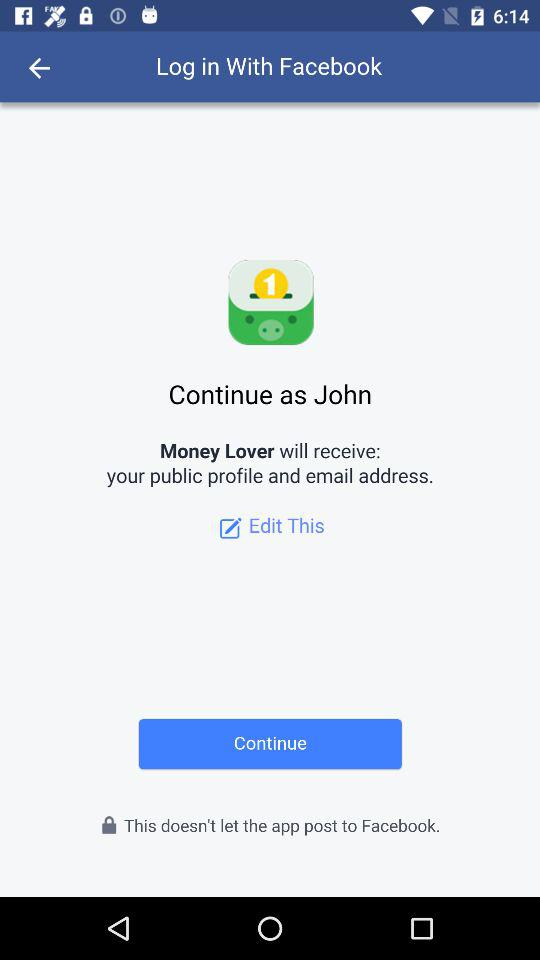How many options do we have to edit profile?
When the provided information is insufficient, respond with <no answer>. <no answer> 